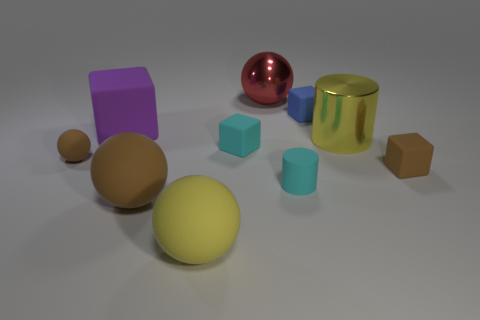What is the spatial relationship between the blue cube and the yellow sphere? The small blue cube is positioned to the left and slightly in front of the yellow sphere. In terms of spatial hierarchy, the blue cube is closer to the vantage point of the observer, while the yellow sphere has a more centered and background placement in the composition. 